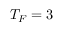Convert formula to latex. <formula><loc_0><loc_0><loc_500><loc_500>T _ { F } = 3</formula> 